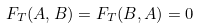<formula> <loc_0><loc_0><loc_500><loc_500>F _ { T } ( A , B ) = F _ { T } ( B , A ) = 0</formula> 